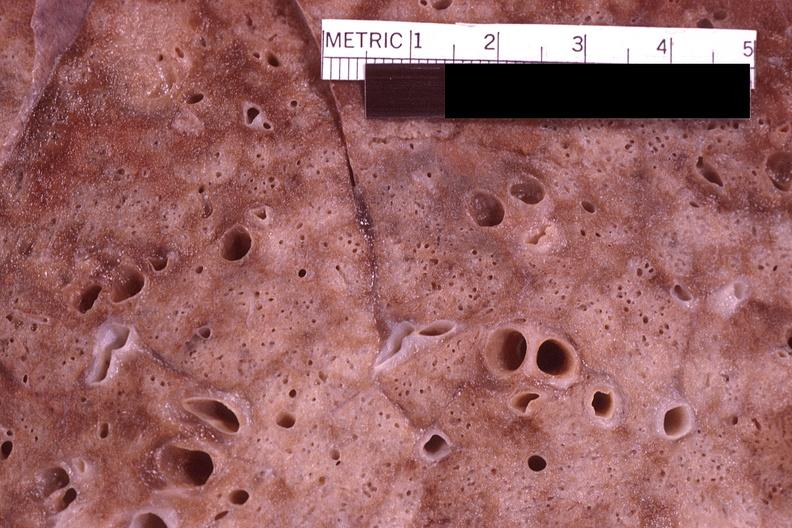does spleen show lung, pneumocystis pneumonia?
Answer the question using a single word or phrase. No 